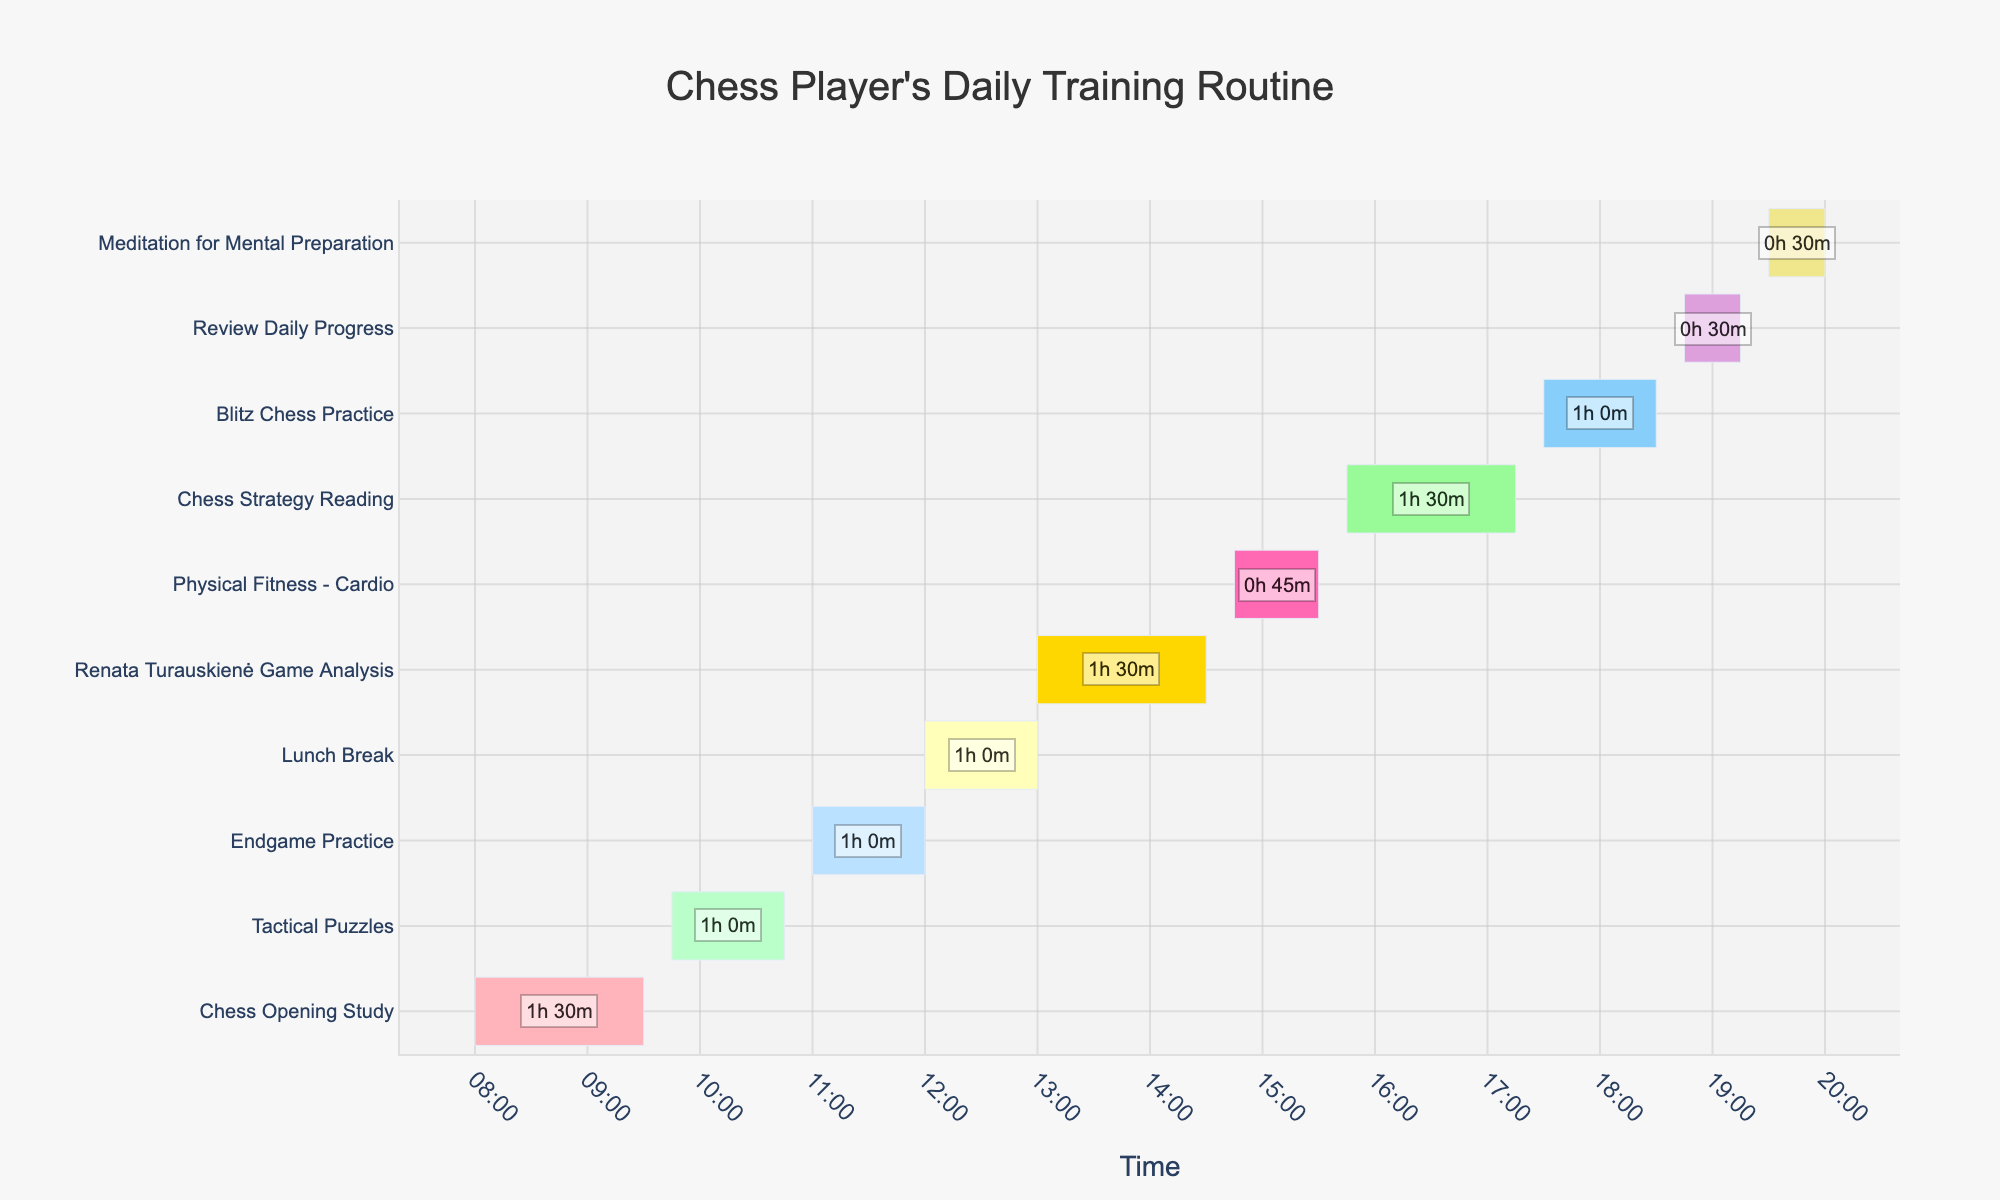What's the first task in the chess player's daily training routine? The first task is located at the top of the Gantt chart and starts at 08:00.
Answer: Chess Opening Study What time does the Lunch Break start and end? Find the "Lunch Break" task and check its time range.
Answer: 12:00 to 13:00 Which task lasts the shortest time? Compare the durations annotated on each task in the Gantt chart to find the shortest.
Answer: Review Daily Progress How long is the Renata Turauskienė Game Analysis session? Look at the duration annotation for the "Renata Turauskienė Game Analysis" task.
Answer: 1h 30m What's the total duration of all physical fitness activities? Identify the task related to physical fitness and sum their durations.
Answer: 0h 45m (Physical Fitness - Cardio) How does the duration of Chess Opening Study compare to that of Blitz Chess Practice? Compare the durations annotated for "Chess Opening Study" and "Blitz Chess Practice".
Answer: Chess Opening Study is longer Which tasks occur immediately after breaks? Identify the tasks that follow "Lunch Break" and other breaks.
Answer: Renata Turauskienė Game Analysis, Meditation for Mental Preparation What tasks follow Lunch Break? Look at the "Lunch Break" task and find the next one.
Answer: Renata Turauskienė Game Analysis How much time is allocated to mental preparation activities? Sum durations of activities related to mental preparation, such as "Meditation for Mental Preparation".
Answer: 0h 30m What is the latest task in the daily routine? Check the task that ends at the latest time in the Gantt chart.
Answer: Meditation for Mental Preparation 